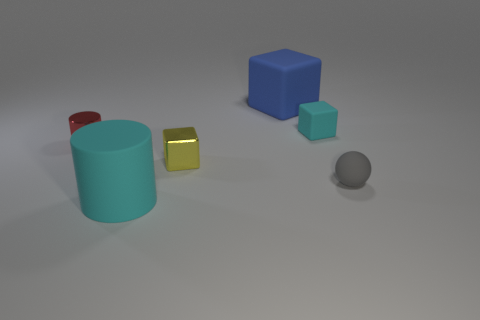There is a cyan thing in front of the shiny object to the right of the red thing; what size is it?
Provide a short and direct response. Large. There is a blue matte thing; does it have the same size as the object right of the cyan cube?
Your answer should be very brief. No. There is a metallic block; what number of cyan things are to the left of it?
Provide a short and direct response. 1. What color is the other large object that is the same shape as the red thing?
Your answer should be very brief. Cyan. How many shiny objects are green cylinders or blue things?
Your answer should be very brief. 0. There is a thing behind the cyan thing behind the red cylinder; is there a tiny block that is on the right side of it?
Your response must be concise. Yes. The metallic cube is what color?
Provide a succinct answer. Yellow. Does the metallic thing that is on the right side of the small red cylinder have the same shape as the tiny cyan rubber object?
Your answer should be very brief. Yes. How many objects are either blue shiny cubes or big objects to the left of the blue thing?
Give a very brief answer. 1. Do the cube that is in front of the small cyan thing and the sphere have the same material?
Your answer should be very brief. No. 